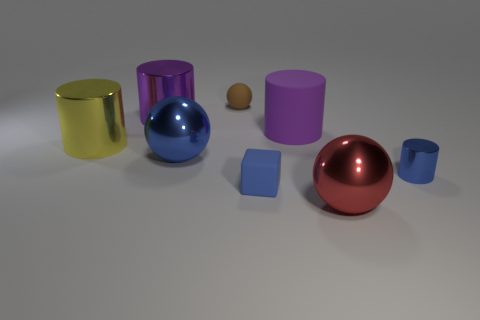Are there any other things that have the same material as the red thing?
Give a very brief answer. Yes. Do the tiny metallic cylinder and the matte block have the same color?
Offer a very short reply. Yes. There is a metal object that is right of the red metal sphere; does it have the same shape as the small matte object that is behind the big yellow metal cylinder?
Offer a very short reply. No. There is a large metallic ball behind the small rubber thing right of the small brown rubber thing; what number of big metal cylinders are in front of it?
Make the answer very short. 0. What is the material of the sphere behind the cylinder that is on the left side of the metal thing behind the yellow object?
Give a very brief answer. Rubber. Is the tiny thing that is on the right side of the tiny blue rubber cube made of the same material as the yellow object?
Keep it short and to the point. Yes. What number of yellow cylinders have the same size as the brown rubber object?
Give a very brief answer. 0. Is the number of small matte objects behind the big yellow object greater than the number of tiny metallic things that are on the left side of the big red sphere?
Offer a very short reply. Yes. Are there any other small metal things that have the same shape as the purple shiny thing?
Your answer should be very brief. Yes. There is a cylinder that is left of the large shiny cylinder that is behind the yellow object; what is its size?
Give a very brief answer. Large. 